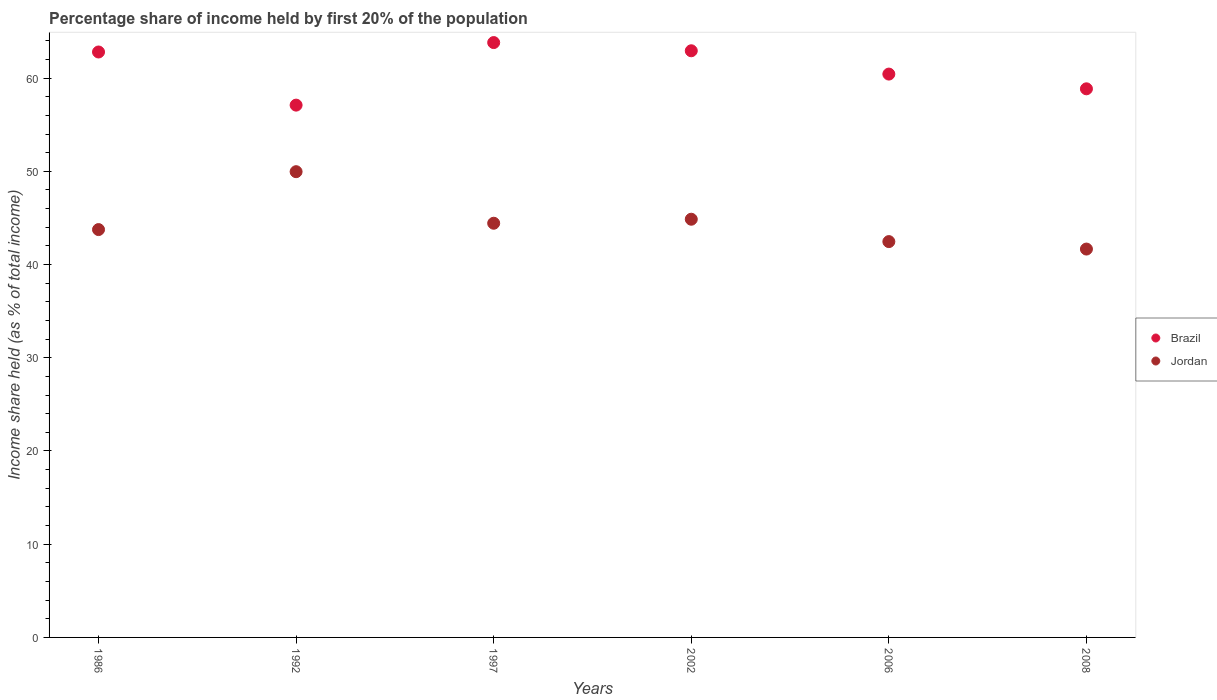How many different coloured dotlines are there?
Your answer should be very brief. 2. What is the share of income held by first 20% of the population in Brazil in 1992?
Your response must be concise. 57.1. Across all years, what is the maximum share of income held by first 20% of the population in Jordan?
Your answer should be very brief. 49.96. Across all years, what is the minimum share of income held by first 20% of the population in Brazil?
Your answer should be compact. 57.1. In which year was the share of income held by first 20% of the population in Brazil maximum?
Provide a succinct answer. 1997. What is the total share of income held by first 20% of the population in Jordan in the graph?
Your answer should be compact. 267.12. What is the difference between the share of income held by first 20% of the population in Brazil in 1992 and that in 2006?
Offer a terse response. -3.33. What is the difference between the share of income held by first 20% of the population in Brazil in 2002 and the share of income held by first 20% of the population in Jordan in 1986?
Provide a short and direct response. 19.18. What is the average share of income held by first 20% of the population in Jordan per year?
Your answer should be very brief. 44.52. In the year 2002, what is the difference between the share of income held by first 20% of the population in Brazil and share of income held by first 20% of the population in Jordan?
Give a very brief answer. 18.07. In how many years, is the share of income held by first 20% of the population in Brazil greater than 10 %?
Give a very brief answer. 6. What is the ratio of the share of income held by first 20% of the population in Brazil in 2002 to that in 2006?
Ensure brevity in your answer.  1.04. Is the share of income held by first 20% of the population in Brazil in 2002 less than that in 2006?
Provide a short and direct response. No. What is the difference between the highest and the second highest share of income held by first 20% of the population in Brazil?
Provide a short and direct response. 0.88. What is the difference between the highest and the lowest share of income held by first 20% of the population in Jordan?
Make the answer very short. 8.3. In how many years, is the share of income held by first 20% of the population in Jordan greater than the average share of income held by first 20% of the population in Jordan taken over all years?
Offer a very short reply. 2. Is the sum of the share of income held by first 20% of the population in Jordan in 2006 and 2008 greater than the maximum share of income held by first 20% of the population in Brazil across all years?
Offer a very short reply. Yes. Is the share of income held by first 20% of the population in Jordan strictly greater than the share of income held by first 20% of the population in Brazil over the years?
Offer a very short reply. No. Is the share of income held by first 20% of the population in Brazil strictly less than the share of income held by first 20% of the population in Jordan over the years?
Your response must be concise. No. Does the graph contain any zero values?
Make the answer very short. No. Does the graph contain grids?
Ensure brevity in your answer.  No. How many legend labels are there?
Your response must be concise. 2. How are the legend labels stacked?
Your answer should be very brief. Vertical. What is the title of the graph?
Offer a terse response. Percentage share of income held by first 20% of the population. Does "Liechtenstein" appear as one of the legend labels in the graph?
Offer a terse response. No. What is the label or title of the X-axis?
Offer a terse response. Years. What is the label or title of the Y-axis?
Your response must be concise. Income share held (as % of total income). What is the Income share held (as % of total income) of Brazil in 1986?
Give a very brief answer. 62.8. What is the Income share held (as % of total income) in Jordan in 1986?
Offer a terse response. 43.75. What is the Income share held (as % of total income) in Brazil in 1992?
Your response must be concise. 57.1. What is the Income share held (as % of total income) of Jordan in 1992?
Provide a succinct answer. 49.96. What is the Income share held (as % of total income) of Brazil in 1997?
Make the answer very short. 63.81. What is the Income share held (as % of total income) in Jordan in 1997?
Your answer should be very brief. 44.43. What is the Income share held (as % of total income) of Brazil in 2002?
Your response must be concise. 62.93. What is the Income share held (as % of total income) of Jordan in 2002?
Offer a terse response. 44.86. What is the Income share held (as % of total income) of Brazil in 2006?
Provide a succinct answer. 60.43. What is the Income share held (as % of total income) in Jordan in 2006?
Your answer should be very brief. 42.46. What is the Income share held (as % of total income) in Brazil in 2008?
Provide a succinct answer. 58.85. What is the Income share held (as % of total income) in Jordan in 2008?
Give a very brief answer. 41.66. Across all years, what is the maximum Income share held (as % of total income) in Brazil?
Your response must be concise. 63.81. Across all years, what is the maximum Income share held (as % of total income) in Jordan?
Offer a very short reply. 49.96. Across all years, what is the minimum Income share held (as % of total income) in Brazil?
Your answer should be compact. 57.1. Across all years, what is the minimum Income share held (as % of total income) in Jordan?
Keep it short and to the point. 41.66. What is the total Income share held (as % of total income) of Brazil in the graph?
Your answer should be compact. 365.92. What is the total Income share held (as % of total income) in Jordan in the graph?
Offer a very short reply. 267.12. What is the difference between the Income share held (as % of total income) of Brazil in 1986 and that in 1992?
Ensure brevity in your answer.  5.7. What is the difference between the Income share held (as % of total income) of Jordan in 1986 and that in 1992?
Provide a short and direct response. -6.21. What is the difference between the Income share held (as % of total income) in Brazil in 1986 and that in 1997?
Your response must be concise. -1.01. What is the difference between the Income share held (as % of total income) in Jordan in 1986 and that in 1997?
Keep it short and to the point. -0.68. What is the difference between the Income share held (as % of total income) in Brazil in 1986 and that in 2002?
Provide a succinct answer. -0.13. What is the difference between the Income share held (as % of total income) in Jordan in 1986 and that in 2002?
Give a very brief answer. -1.11. What is the difference between the Income share held (as % of total income) in Brazil in 1986 and that in 2006?
Keep it short and to the point. 2.37. What is the difference between the Income share held (as % of total income) in Jordan in 1986 and that in 2006?
Make the answer very short. 1.29. What is the difference between the Income share held (as % of total income) in Brazil in 1986 and that in 2008?
Ensure brevity in your answer.  3.95. What is the difference between the Income share held (as % of total income) of Jordan in 1986 and that in 2008?
Make the answer very short. 2.09. What is the difference between the Income share held (as % of total income) of Brazil in 1992 and that in 1997?
Offer a terse response. -6.71. What is the difference between the Income share held (as % of total income) of Jordan in 1992 and that in 1997?
Provide a short and direct response. 5.53. What is the difference between the Income share held (as % of total income) in Brazil in 1992 and that in 2002?
Provide a short and direct response. -5.83. What is the difference between the Income share held (as % of total income) of Jordan in 1992 and that in 2002?
Your answer should be very brief. 5.1. What is the difference between the Income share held (as % of total income) in Brazil in 1992 and that in 2006?
Make the answer very short. -3.33. What is the difference between the Income share held (as % of total income) in Jordan in 1992 and that in 2006?
Your answer should be very brief. 7.5. What is the difference between the Income share held (as % of total income) of Brazil in 1992 and that in 2008?
Offer a terse response. -1.75. What is the difference between the Income share held (as % of total income) of Jordan in 1997 and that in 2002?
Offer a very short reply. -0.43. What is the difference between the Income share held (as % of total income) in Brazil in 1997 and that in 2006?
Provide a succinct answer. 3.38. What is the difference between the Income share held (as % of total income) of Jordan in 1997 and that in 2006?
Your response must be concise. 1.97. What is the difference between the Income share held (as % of total income) of Brazil in 1997 and that in 2008?
Ensure brevity in your answer.  4.96. What is the difference between the Income share held (as % of total income) in Jordan in 1997 and that in 2008?
Offer a terse response. 2.77. What is the difference between the Income share held (as % of total income) of Brazil in 2002 and that in 2008?
Provide a succinct answer. 4.08. What is the difference between the Income share held (as % of total income) of Jordan in 2002 and that in 2008?
Make the answer very short. 3.2. What is the difference between the Income share held (as % of total income) in Brazil in 2006 and that in 2008?
Make the answer very short. 1.58. What is the difference between the Income share held (as % of total income) of Jordan in 2006 and that in 2008?
Give a very brief answer. 0.8. What is the difference between the Income share held (as % of total income) in Brazil in 1986 and the Income share held (as % of total income) in Jordan in 1992?
Provide a short and direct response. 12.84. What is the difference between the Income share held (as % of total income) in Brazil in 1986 and the Income share held (as % of total income) in Jordan in 1997?
Provide a short and direct response. 18.37. What is the difference between the Income share held (as % of total income) in Brazil in 1986 and the Income share held (as % of total income) in Jordan in 2002?
Keep it short and to the point. 17.94. What is the difference between the Income share held (as % of total income) of Brazil in 1986 and the Income share held (as % of total income) of Jordan in 2006?
Provide a short and direct response. 20.34. What is the difference between the Income share held (as % of total income) in Brazil in 1986 and the Income share held (as % of total income) in Jordan in 2008?
Offer a very short reply. 21.14. What is the difference between the Income share held (as % of total income) in Brazil in 1992 and the Income share held (as % of total income) in Jordan in 1997?
Provide a short and direct response. 12.67. What is the difference between the Income share held (as % of total income) of Brazil in 1992 and the Income share held (as % of total income) of Jordan in 2002?
Your answer should be compact. 12.24. What is the difference between the Income share held (as % of total income) in Brazil in 1992 and the Income share held (as % of total income) in Jordan in 2006?
Provide a short and direct response. 14.64. What is the difference between the Income share held (as % of total income) in Brazil in 1992 and the Income share held (as % of total income) in Jordan in 2008?
Give a very brief answer. 15.44. What is the difference between the Income share held (as % of total income) of Brazil in 1997 and the Income share held (as % of total income) of Jordan in 2002?
Offer a very short reply. 18.95. What is the difference between the Income share held (as % of total income) of Brazil in 1997 and the Income share held (as % of total income) of Jordan in 2006?
Offer a very short reply. 21.35. What is the difference between the Income share held (as % of total income) of Brazil in 1997 and the Income share held (as % of total income) of Jordan in 2008?
Your answer should be compact. 22.15. What is the difference between the Income share held (as % of total income) of Brazil in 2002 and the Income share held (as % of total income) of Jordan in 2006?
Provide a short and direct response. 20.47. What is the difference between the Income share held (as % of total income) in Brazil in 2002 and the Income share held (as % of total income) in Jordan in 2008?
Offer a terse response. 21.27. What is the difference between the Income share held (as % of total income) of Brazil in 2006 and the Income share held (as % of total income) of Jordan in 2008?
Ensure brevity in your answer.  18.77. What is the average Income share held (as % of total income) in Brazil per year?
Keep it short and to the point. 60.99. What is the average Income share held (as % of total income) in Jordan per year?
Your answer should be compact. 44.52. In the year 1986, what is the difference between the Income share held (as % of total income) of Brazil and Income share held (as % of total income) of Jordan?
Keep it short and to the point. 19.05. In the year 1992, what is the difference between the Income share held (as % of total income) of Brazil and Income share held (as % of total income) of Jordan?
Give a very brief answer. 7.14. In the year 1997, what is the difference between the Income share held (as % of total income) in Brazil and Income share held (as % of total income) in Jordan?
Your answer should be compact. 19.38. In the year 2002, what is the difference between the Income share held (as % of total income) of Brazil and Income share held (as % of total income) of Jordan?
Provide a short and direct response. 18.07. In the year 2006, what is the difference between the Income share held (as % of total income) of Brazil and Income share held (as % of total income) of Jordan?
Give a very brief answer. 17.97. In the year 2008, what is the difference between the Income share held (as % of total income) of Brazil and Income share held (as % of total income) of Jordan?
Your answer should be very brief. 17.19. What is the ratio of the Income share held (as % of total income) of Brazil in 1986 to that in 1992?
Ensure brevity in your answer.  1.1. What is the ratio of the Income share held (as % of total income) in Jordan in 1986 to that in 1992?
Your response must be concise. 0.88. What is the ratio of the Income share held (as % of total income) in Brazil in 1986 to that in 1997?
Make the answer very short. 0.98. What is the ratio of the Income share held (as % of total income) in Jordan in 1986 to that in 1997?
Offer a terse response. 0.98. What is the ratio of the Income share held (as % of total income) in Brazil in 1986 to that in 2002?
Give a very brief answer. 1. What is the ratio of the Income share held (as % of total income) in Jordan in 1986 to that in 2002?
Your answer should be very brief. 0.98. What is the ratio of the Income share held (as % of total income) of Brazil in 1986 to that in 2006?
Offer a terse response. 1.04. What is the ratio of the Income share held (as % of total income) of Jordan in 1986 to that in 2006?
Your answer should be compact. 1.03. What is the ratio of the Income share held (as % of total income) in Brazil in 1986 to that in 2008?
Keep it short and to the point. 1.07. What is the ratio of the Income share held (as % of total income) in Jordan in 1986 to that in 2008?
Give a very brief answer. 1.05. What is the ratio of the Income share held (as % of total income) in Brazil in 1992 to that in 1997?
Your answer should be very brief. 0.89. What is the ratio of the Income share held (as % of total income) of Jordan in 1992 to that in 1997?
Ensure brevity in your answer.  1.12. What is the ratio of the Income share held (as % of total income) in Brazil in 1992 to that in 2002?
Your answer should be compact. 0.91. What is the ratio of the Income share held (as % of total income) in Jordan in 1992 to that in 2002?
Your response must be concise. 1.11. What is the ratio of the Income share held (as % of total income) in Brazil in 1992 to that in 2006?
Keep it short and to the point. 0.94. What is the ratio of the Income share held (as % of total income) in Jordan in 1992 to that in 2006?
Offer a very short reply. 1.18. What is the ratio of the Income share held (as % of total income) of Brazil in 1992 to that in 2008?
Ensure brevity in your answer.  0.97. What is the ratio of the Income share held (as % of total income) of Jordan in 1992 to that in 2008?
Keep it short and to the point. 1.2. What is the ratio of the Income share held (as % of total income) in Jordan in 1997 to that in 2002?
Your response must be concise. 0.99. What is the ratio of the Income share held (as % of total income) in Brazil in 1997 to that in 2006?
Provide a succinct answer. 1.06. What is the ratio of the Income share held (as % of total income) in Jordan in 1997 to that in 2006?
Provide a short and direct response. 1.05. What is the ratio of the Income share held (as % of total income) in Brazil in 1997 to that in 2008?
Your answer should be compact. 1.08. What is the ratio of the Income share held (as % of total income) in Jordan in 1997 to that in 2008?
Your answer should be compact. 1.07. What is the ratio of the Income share held (as % of total income) of Brazil in 2002 to that in 2006?
Provide a succinct answer. 1.04. What is the ratio of the Income share held (as % of total income) in Jordan in 2002 to that in 2006?
Offer a very short reply. 1.06. What is the ratio of the Income share held (as % of total income) of Brazil in 2002 to that in 2008?
Ensure brevity in your answer.  1.07. What is the ratio of the Income share held (as % of total income) in Jordan in 2002 to that in 2008?
Your answer should be very brief. 1.08. What is the ratio of the Income share held (as % of total income) of Brazil in 2006 to that in 2008?
Your answer should be very brief. 1.03. What is the ratio of the Income share held (as % of total income) in Jordan in 2006 to that in 2008?
Keep it short and to the point. 1.02. What is the difference between the highest and the lowest Income share held (as % of total income) in Brazil?
Provide a short and direct response. 6.71. 